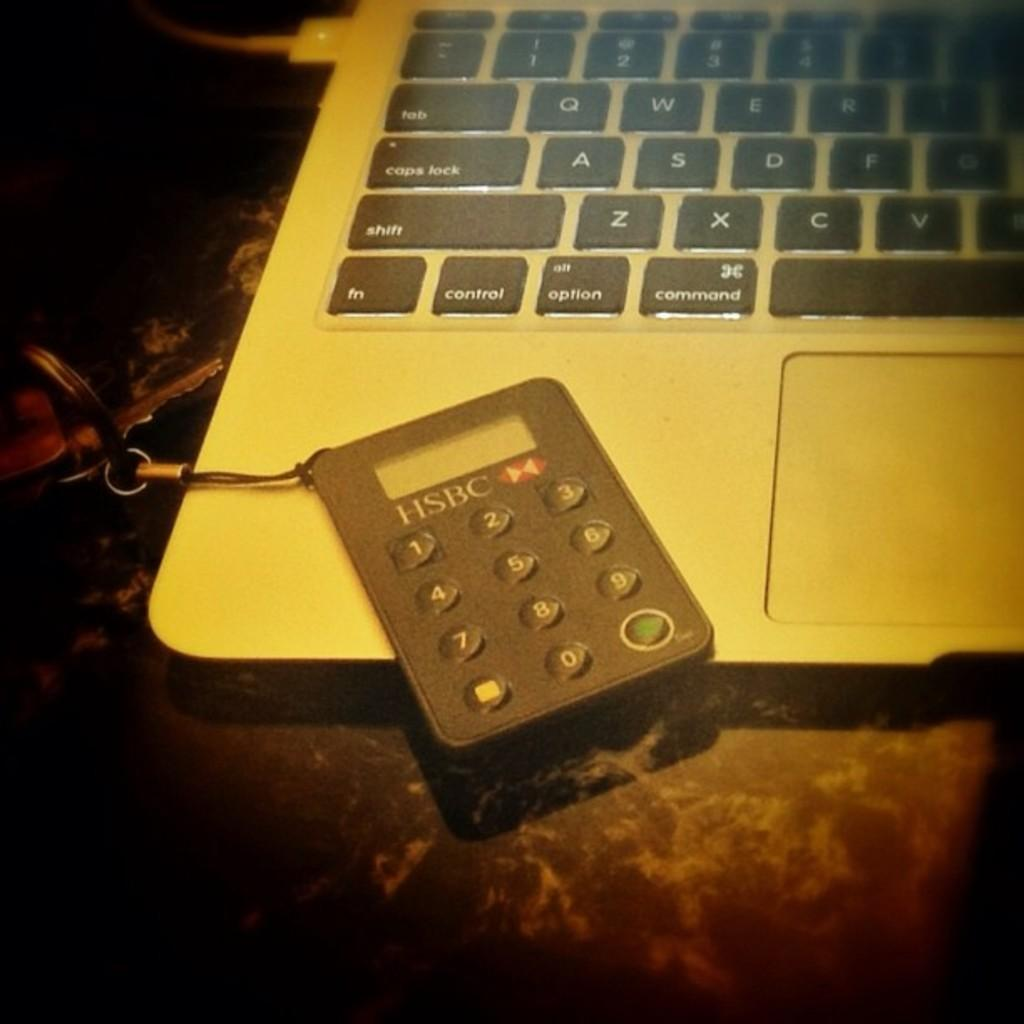<image>
Share a concise interpretation of the image provided. An HSBC keypad attached to a keychain that is resting on top of a Mac laptop keyboard. 